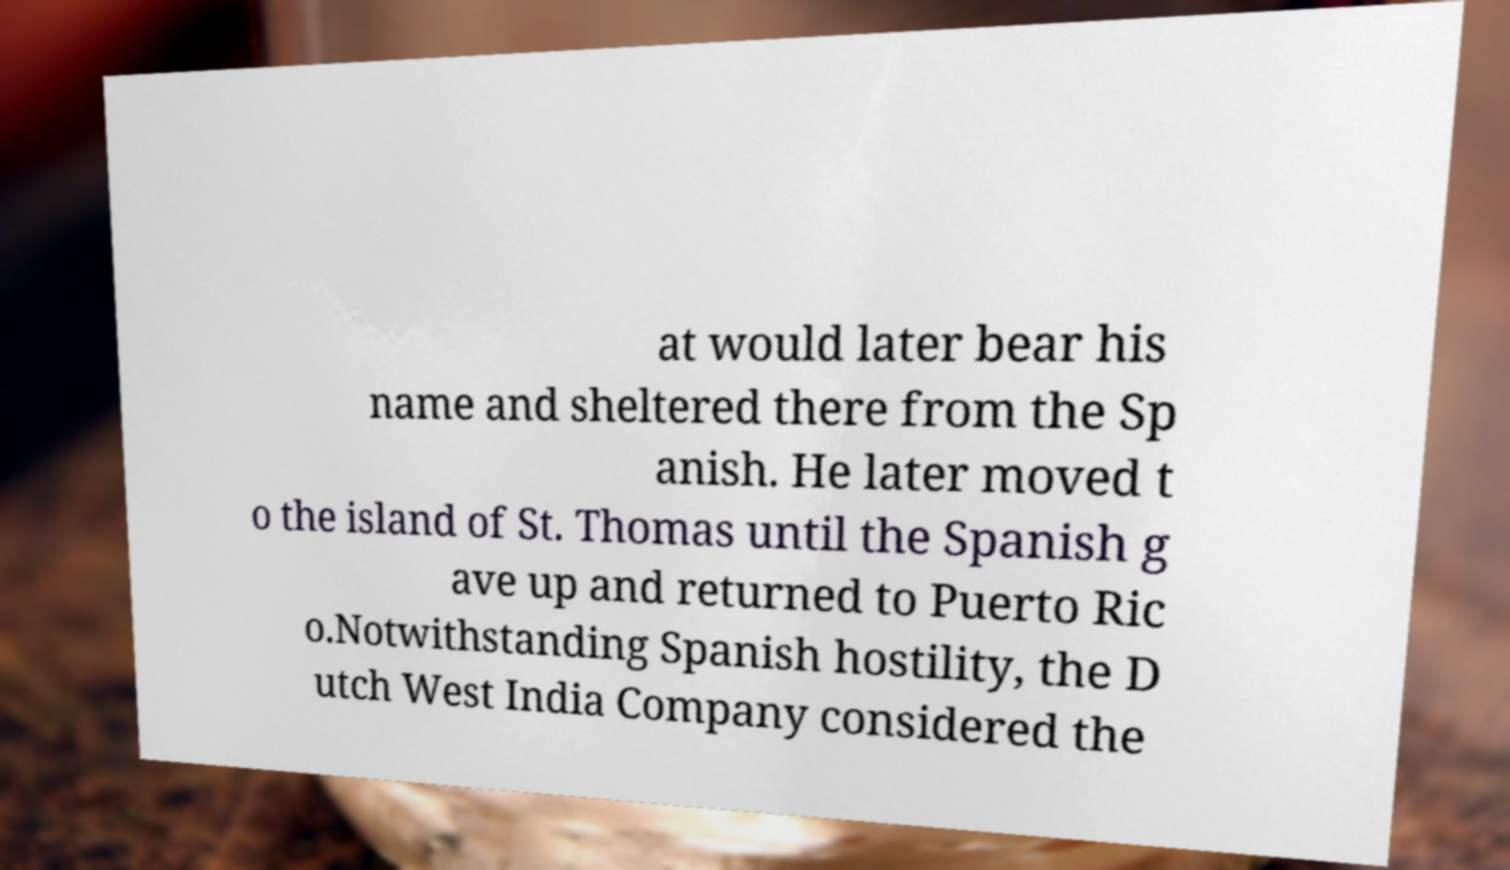What messages or text are displayed in this image? I need them in a readable, typed format. at would later bear his name and sheltered there from the Sp anish. He later moved t o the island of St. Thomas until the Spanish g ave up and returned to Puerto Ric o.Notwithstanding Spanish hostility, the D utch West India Company considered the 